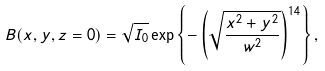<formula> <loc_0><loc_0><loc_500><loc_500>B ( x , y , z = 0 ) = \sqrt { I _ { 0 } } \exp \left \{ - \left ( \sqrt { \frac { x ^ { 2 } + y ^ { 2 } } { w ^ { 2 } } } \right ) ^ { 1 4 } \right \} ,</formula> 